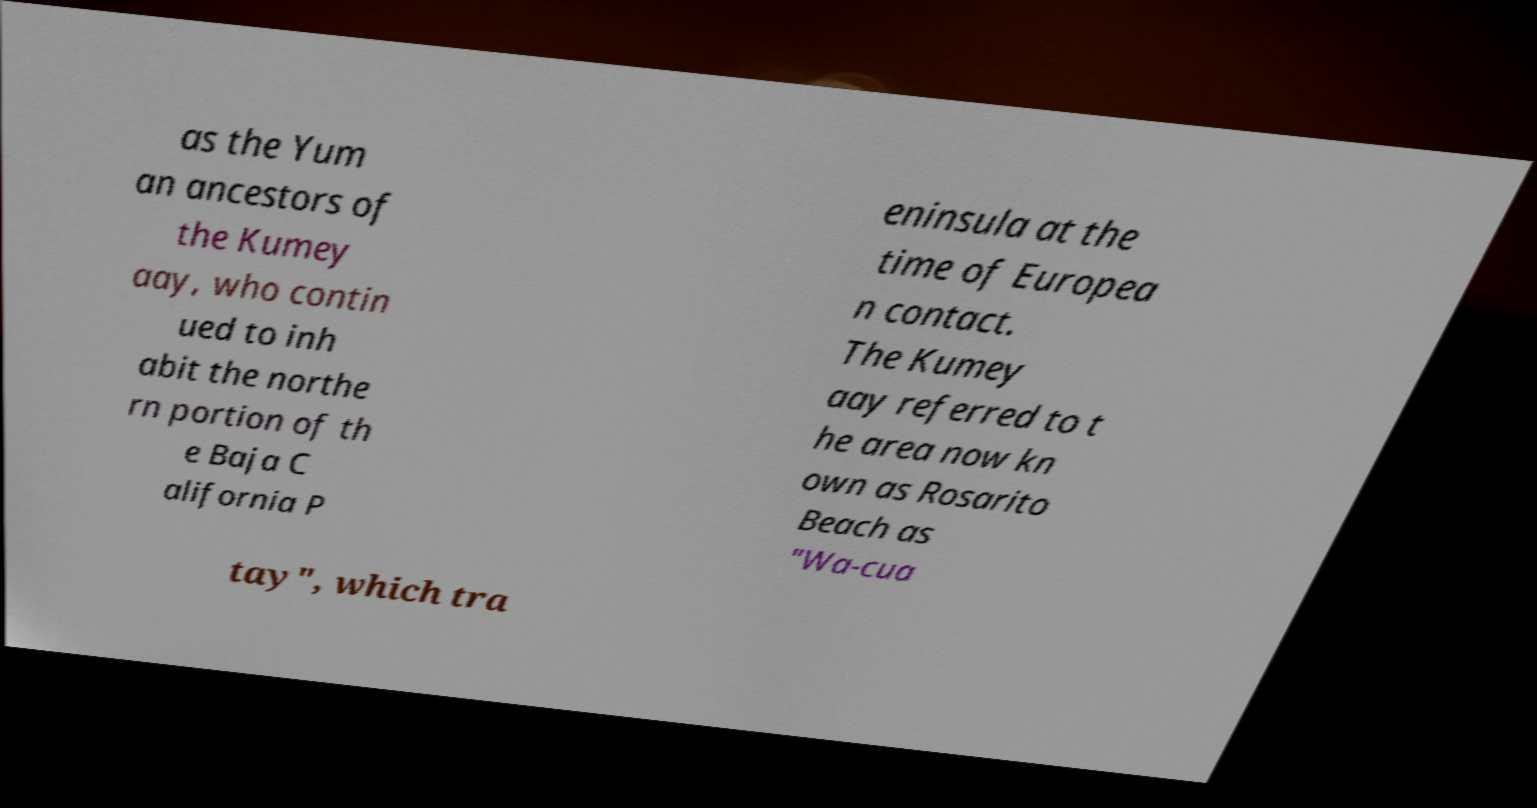What messages or text are displayed in this image? I need them in a readable, typed format. as the Yum an ancestors of the Kumey aay, who contin ued to inh abit the northe rn portion of th e Baja C alifornia P eninsula at the time of Europea n contact. The Kumey aay referred to t he area now kn own as Rosarito Beach as "Wa-cua tay", which tra 